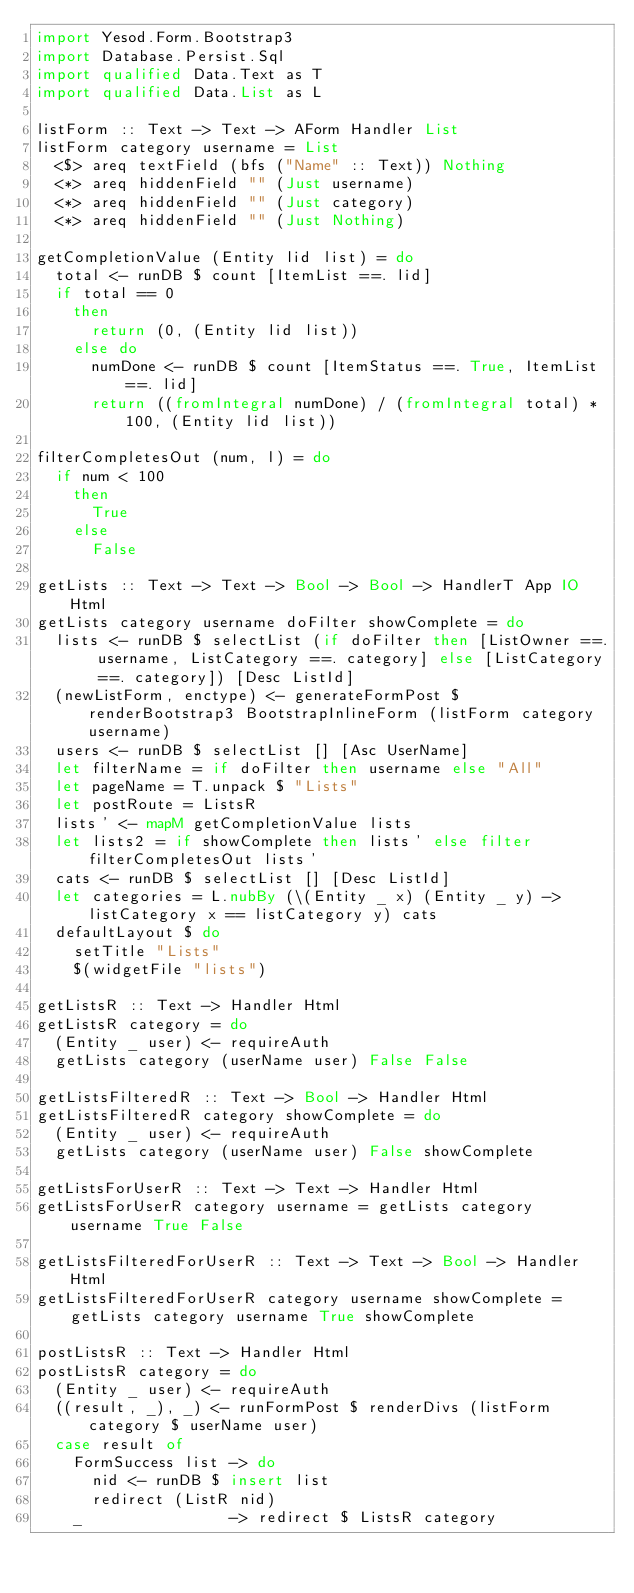Convert code to text. <code><loc_0><loc_0><loc_500><loc_500><_Haskell_>import Yesod.Form.Bootstrap3
import Database.Persist.Sql
import qualified Data.Text as T
import qualified Data.List as L

listForm :: Text -> Text -> AForm Handler List
listForm category username = List
  <$> areq textField (bfs ("Name" :: Text)) Nothing
  <*> areq hiddenField "" (Just username)
  <*> areq hiddenField "" (Just category)
  <*> areq hiddenField "" (Just Nothing)

getCompletionValue (Entity lid list) = do
  total <- runDB $ count [ItemList ==. lid]
  if total == 0
    then
      return (0, (Entity lid list))
    else do
      numDone <- runDB $ count [ItemStatus ==. True, ItemList ==. lid]
      return ((fromIntegral numDone) / (fromIntegral total) * 100, (Entity lid list))

filterCompletesOut (num, l) = do
  if num < 100
    then
      True
    else
      False

getLists :: Text -> Text -> Bool -> Bool -> HandlerT App IO Html
getLists category username doFilter showComplete = do
  lists <- runDB $ selectList (if doFilter then [ListOwner ==. username, ListCategory ==. category] else [ListCategory ==. category]) [Desc ListId]
  (newListForm, enctype) <- generateFormPost $ renderBootstrap3 BootstrapInlineForm (listForm category username)
  users <- runDB $ selectList [] [Asc UserName]
  let filterName = if doFilter then username else "All"
  let pageName = T.unpack $ "Lists"
  let postRoute = ListsR
  lists' <- mapM getCompletionValue lists
  let lists2 = if showComplete then lists' else filter filterCompletesOut lists'
  cats <- runDB $ selectList [] [Desc ListId]
  let categories = L.nubBy (\(Entity _ x) (Entity _ y) -> listCategory x == listCategory y) cats
  defaultLayout $ do
    setTitle "Lists"
    $(widgetFile "lists")

getListsR :: Text -> Handler Html
getListsR category = do
  (Entity _ user) <- requireAuth
  getLists category (userName user) False False

getListsFilteredR :: Text -> Bool -> Handler Html
getListsFilteredR category showComplete = do
  (Entity _ user) <- requireAuth
  getLists category (userName user) False showComplete

getListsForUserR :: Text -> Text -> Handler Html
getListsForUserR category username = getLists category username True False

getListsFilteredForUserR :: Text -> Text -> Bool -> Handler Html
getListsFilteredForUserR category username showComplete = getLists category username True showComplete

postListsR :: Text -> Handler Html
postListsR category = do
  (Entity _ user) <- requireAuth
  ((result, _), _) <- runFormPost $ renderDivs (listForm category $ userName user)
  case result of
    FormSuccess list -> do
      nid <- runDB $ insert list
      redirect (ListR nid)
    _                -> redirect $ ListsR category
</code> 